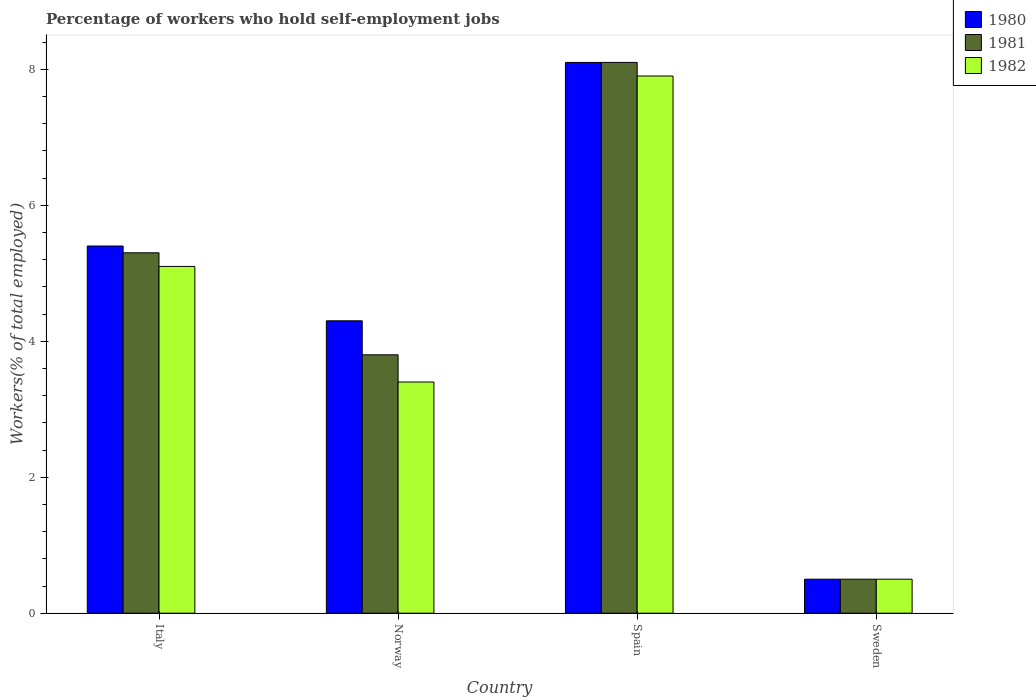How many different coloured bars are there?
Your answer should be very brief. 3. How many groups of bars are there?
Your answer should be very brief. 4. Are the number of bars per tick equal to the number of legend labels?
Give a very brief answer. Yes. How many bars are there on the 1st tick from the left?
Provide a succinct answer. 3. What is the label of the 1st group of bars from the left?
Provide a short and direct response. Italy. What is the percentage of self-employed workers in 1981 in Spain?
Your response must be concise. 8.1. Across all countries, what is the maximum percentage of self-employed workers in 1981?
Your answer should be compact. 8.1. Across all countries, what is the minimum percentage of self-employed workers in 1981?
Keep it short and to the point. 0.5. What is the total percentage of self-employed workers in 1980 in the graph?
Your response must be concise. 18.3. What is the difference between the percentage of self-employed workers in 1982 in Italy and that in Norway?
Provide a short and direct response. 1.7. What is the difference between the percentage of self-employed workers in 1980 in Sweden and the percentage of self-employed workers in 1981 in Spain?
Give a very brief answer. -7.6. What is the average percentage of self-employed workers in 1980 per country?
Give a very brief answer. 4.58. What is the difference between the percentage of self-employed workers of/in 1982 and percentage of self-employed workers of/in 1981 in Spain?
Your answer should be compact. -0.2. What is the ratio of the percentage of self-employed workers in 1982 in Italy to that in Sweden?
Your response must be concise. 10.2. Is the difference between the percentage of self-employed workers in 1982 in Norway and Sweden greater than the difference between the percentage of self-employed workers in 1981 in Norway and Sweden?
Your response must be concise. No. What is the difference between the highest and the second highest percentage of self-employed workers in 1980?
Provide a succinct answer. 3.8. What is the difference between the highest and the lowest percentage of self-employed workers in 1981?
Keep it short and to the point. 7.6. In how many countries, is the percentage of self-employed workers in 1982 greater than the average percentage of self-employed workers in 1982 taken over all countries?
Keep it short and to the point. 2. Is the sum of the percentage of self-employed workers in 1982 in Spain and Sweden greater than the maximum percentage of self-employed workers in 1981 across all countries?
Your answer should be compact. Yes. What does the 3rd bar from the left in Sweden represents?
Make the answer very short. 1982. Is it the case that in every country, the sum of the percentage of self-employed workers in 1981 and percentage of self-employed workers in 1980 is greater than the percentage of self-employed workers in 1982?
Offer a terse response. Yes. Are all the bars in the graph horizontal?
Your answer should be compact. No. How many countries are there in the graph?
Your answer should be compact. 4. Are the values on the major ticks of Y-axis written in scientific E-notation?
Offer a very short reply. No. Does the graph contain any zero values?
Offer a terse response. No. Does the graph contain grids?
Keep it short and to the point. No. How are the legend labels stacked?
Make the answer very short. Vertical. What is the title of the graph?
Provide a succinct answer. Percentage of workers who hold self-employment jobs. Does "1978" appear as one of the legend labels in the graph?
Provide a succinct answer. No. What is the label or title of the X-axis?
Your response must be concise. Country. What is the label or title of the Y-axis?
Ensure brevity in your answer.  Workers(% of total employed). What is the Workers(% of total employed) of 1980 in Italy?
Make the answer very short. 5.4. What is the Workers(% of total employed) of 1981 in Italy?
Offer a very short reply. 5.3. What is the Workers(% of total employed) in 1982 in Italy?
Your answer should be compact. 5.1. What is the Workers(% of total employed) in 1980 in Norway?
Offer a very short reply. 4.3. What is the Workers(% of total employed) in 1981 in Norway?
Keep it short and to the point. 3.8. What is the Workers(% of total employed) of 1982 in Norway?
Your answer should be very brief. 3.4. What is the Workers(% of total employed) of 1980 in Spain?
Your response must be concise. 8.1. What is the Workers(% of total employed) in 1981 in Spain?
Ensure brevity in your answer.  8.1. What is the Workers(% of total employed) in 1982 in Spain?
Offer a terse response. 7.9. What is the Workers(% of total employed) in 1981 in Sweden?
Give a very brief answer. 0.5. Across all countries, what is the maximum Workers(% of total employed) in 1980?
Your answer should be compact. 8.1. Across all countries, what is the maximum Workers(% of total employed) of 1981?
Make the answer very short. 8.1. Across all countries, what is the maximum Workers(% of total employed) in 1982?
Keep it short and to the point. 7.9. Across all countries, what is the minimum Workers(% of total employed) in 1980?
Provide a succinct answer. 0.5. Across all countries, what is the minimum Workers(% of total employed) of 1981?
Give a very brief answer. 0.5. Across all countries, what is the minimum Workers(% of total employed) in 1982?
Offer a terse response. 0.5. What is the total Workers(% of total employed) in 1982 in the graph?
Keep it short and to the point. 16.9. What is the difference between the Workers(% of total employed) of 1980 in Italy and that in Norway?
Keep it short and to the point. 1.1. What is the difference between the Workers(% of total employed) of 1982 in Italy and that in Norway?
Your response must be concise. 1.7. What is the difference between the Workers(% of total employed) of 1981 in Italy and that in Spain?
Your answer should be compact. -2.8. What is the difference between the Workers(% of total employed) of 1980 in Italy and that in Sweden?
Your answer should be compact. 4.9. What is the difference between the Workers(% of total employed) in 1982 in Italy and that in Sweden?
Offer a terse response. 4.6. What is the difference between the Workers(% of total employed) in 1980 in Norway and that in Spain?
Ensure brevity in your answer.  -3.8. What is the difference between the Workers(% of total employed) in 1980 in Norway and that in Sweden?
Keep it short and to the point. 3.8. What is the difference between the Workers(% of total employed) in 1981 in Norway and that in Sweden?
Make the answer very short. 3.3. What is the difference between the Workers(% of total employed) in 1982 in Norway and that in Sweden?
Offer a terse response. 2.9. What is the difference between the Workers(% of total employed) in 1980 in Spain and that in Sweden?
Keep it short and to the point. 7.6. What is the difference between the Workers(% of total employed) in 1981 in Spain and that in Sweden?
Offer a terse response. 7.6. What is the difference between the Workers(% of total employed) of 1980 in Italy and the Workers(% of total employed) of 1981 in Norway?
Offer a terse response. 1.6. What is the difference between the Workers(% of total employed) in 1981 in Italy and the Workers(% of total employed) in 1982 in Norway?
Offer a very short reply. 1.9. What is the difference between the Workers(% of total employed) of 1981 in Italy and the Workers(% of total employed) of 1982 in Spain?
Your answer should be compact. -2.6. What is the difference between the Workers(% of total employed) of 1980 in Italy and the Workers(% of total employed) of 1981 in Sweden?
Your answer should be very brief. 4.9. What is the difference between the Workers(% of total employed) in 1980 in Italy and the Workers(% of total employed) in 1982 in Sweden?
Your answer should be compact. 4.9. What is the difference between the Workers(% of total employed) in 1980 in Norway and the Workers(% of total employed) in 1981 in Spain?
Your answer should be compact. -3.8. What is the difference between the Workers(% of total employed) of 1980 in Norway and the Workers(% of total employed) of 1982 in Spain?
Provide a short and direct response. -3.6. What is the difference between the Workers(% of total employed) in 1981 in Norway and the Workers(% of total employed) in 1982 in Spain?
Offer a terse response. -4.1. What is the difference between the Workers(% of total employed) of 1980 in Norway and the Workers(% of total employed) of 1982 in Sweden?
Provide a succinct answer. 3.8. What is the difference between the Workers(% of total employed) of 1981 in Norway and the Workers(% of total employed) of 1982 in Sweden?
Offer a very short reply. 3.3. What is the difference between the Workers(% of total employed) of 1980 in Spain and the Workers(% of total employed) of 1981 in Sweden?
Give a very brief answer. 7.6. What is the difference between the Workers(% of total employed) of 1981 in Spain and the Workers(% of total employed) of 1982 in Sweden?
Ensure brevity in your answer.  7.6. What is the average Workers(% of total employed) in 1980 per country?
Give a very brief answer. 4.58. What is the average Workers(% of total employed) in 1981 per country?
Your answer should be very brief. 4.42. What is the average Workers(% of total employed) in 1982 per country?
Offer a terse response. 4.22. What is the difference between the Workers(% of total employed) in 1980 and Workers(% of total employed) in 1981 in Italy?
Your answer should be very brief. 0.1. What is the difference between the Workers(% of total employed) in 1981 and Workers(% of total employed) in 1982 in Italy?
Your answer should be compact. 0.2. What is the difference between the Workers(% of total employed) in 1981 and Workers(% of total employed) in 1982 in Norway?
Your response must be concise. 0.4. What is the difference between the Workers(% of total employed) of 1980 and Workers(% of total employed) of 1981 in Spain?
Make the answer very short. 0. What is the difference between the Workers(% of total employed) in 1981 and Workers(% of total employed) in 1982 in Spain?
Keep it short and to the point. 0.2. What is the difference between the Workers(% of total employed) in 1980 and Workers(% of total employed) in 1982 in Sweden?
Your response must be concise. 0. What is the ratio of the Workers(% of total employed) in 1980 in Italy to that in Norway?
Your answer should be very brief. 1.26. What is the ratio of the Workers(% of total employed) of 1981 in Italy to that in Norway?
Keep it short and to the point. 1.39. What is the ratio of the Workers(% of total employed) in 1980 in Italy to that in Spain?
Offer a terse response. 0.67. What is the ratio of the Workers(% of total employed) of 1981 in Italy to that in Spain?
Your response must be concise. 0.65. What is the ratio of the Workers(% of total employed) of 1982 in Italy to that in Spain?
Keep it short and to the point. 0.65. What is the ratio of the Workers(% of total employed) of 1980 in Italy to that in Sweden?
Keep it short and to the point. 10.8. What is the ratio of the Workers(% of total employed) in 1981 in Italy to that in Sweden?
Your answer should be very brief. 10.6. What is the ratio of the Workers(% of total employed) in 1982 in Italy to that in Sweden?
Offer a very short reply. 10.2. What is the ratio of the Workers(% of total employed) of 1980 in Norway to that in Spain?
Give a very brief answer. 0.53. What is the ratio of the Workers(% of total employed) in 1981 in Norway to that in Spain?
Your response must be concise. 0.47. What is the ratio of the Workers(% of total employed) of 1982 in Norway to that in Spain?
Your answer should be very brief. 0.43. What is the ratio of the Workers(% of total employed) in 1980 in Norway to that in Sweden?
Ensure brevity in your answer.  8.6. What is the ratio of the Workers(% of total employed) of 1981 in Norway to that in Sweden?
Your response must be concise. 7.6. What is the ratio of the Workers(% of total employed) in 1981 in Spain to that in Sweden?
Offer a very short reply. 16.2. What is the ratio of the Workers(% of total employed) of 1982 in Spain to that in Sweden?
Provide a short and direct response. 15.8. What is the difference between the highest and the second highest Workers(% of total employed) of 1981?
Provide a succinct answer. 2.8. What is the difference between the highest and the second highest Workers(% of total employed) of 1982?
Your answer should be very brief. 2.8. What is the difference between the highest and the lowest Workers(% of total employed) in 1980?
Provide a short and direct response. 7.6. What is the difference between the highest and the lowest Workers(% of total employed) in 1981?
Provide a short and direct response. 7.6. What is the difference between the highest and the lowest Workers(% of total employed) of 1982?
Ensure brevity in your answer.  7.4. 